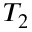<formula> <loc_0><loc_0><loc_500><loc_500>T _ { 2 }</formula> 